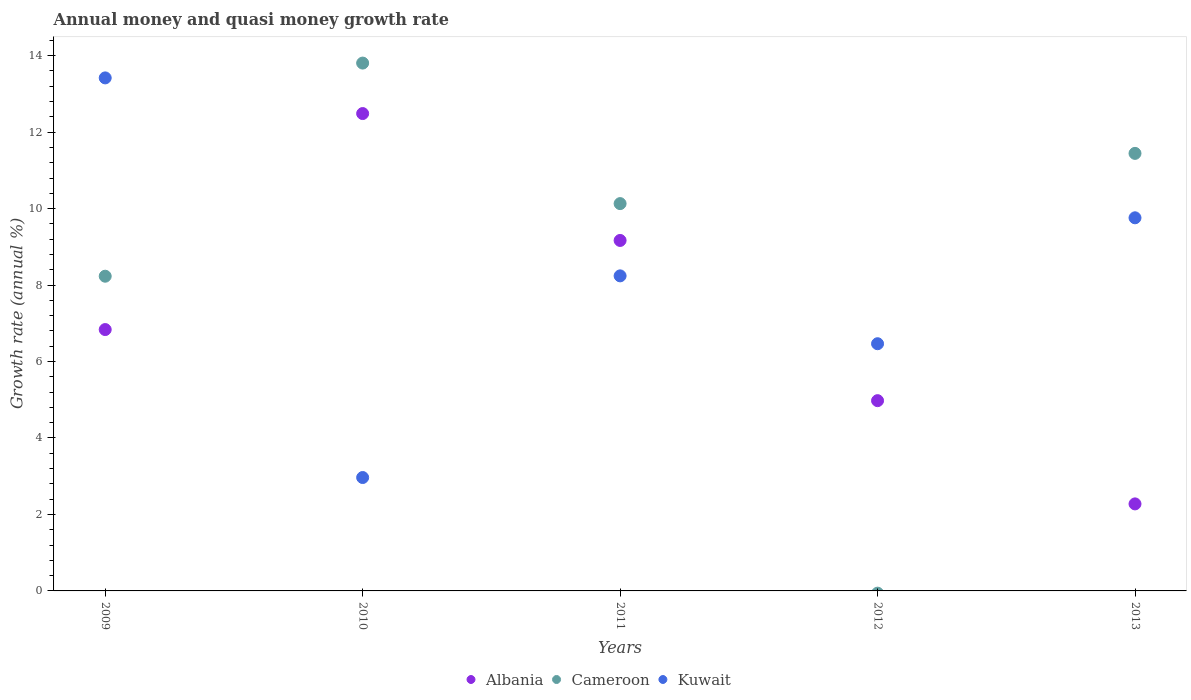Is the number of dotlines equal to the number of legend labels?
Your answer should be compact. No. What is the growth rate in Albania in 2009?
Ensure brevity in your answer.  6.84. Across all years, what is the maximum growth rate in Cameroon?
Provide a succinct answer. 13.81. Across all years, what is the minimum growth rate in Albania?
Your answer should be very brief. 2.28. What is the total growth rate in Kuwait in the graph?
Offer a very short reply. 40.85. What is the difference between the growth rate in Cameroon in 2010 and that in 2013?
Provide a succinct answer. 2.36. What is the difference between the growth rate in Kuwait in 2009 and the growth rate in Cameroon in 2010?
Provide a succinct answer. -0.39. What is the average growth rate in Albania per year?
Ensure brevity in your answer.  7.15. In the year 2010, what is the difference between the growth rate in Cameroon and growth rate in Albania?
Provide a succinct answer. 1.32. In how many years, is the growth rate in Cameroon greater than 8.4 %?
Keep it short and to the point. 3. What is the ratio of the growth rate in Cameroon in 2010 to that in 2013?
Keep it short and to the point. 1.21. Is the difference between the growth rate in Cameroon in 2011 and 2013 greater than the difference between the growth rate in Albania in 2011 and 2013?
Provide a short and direct response. No. What is the difference between the highest and the second highest growth rate in Albania?
Provide a short and direct response. 3.32. What is the difference between the highest and the lowest growth rate in Albania?
Keep it short and to the point. 10.21. In how many years, is the growth rate in Cameroon greater than the average growth rate in Cameroon taken over all years?
Your answer should be very brief. 3. Is it the case that in every year, the sum of the growth rate in Cameroon and growth rate in Albania  is greater than the growth rate in Kuwait?
Offer a terse response. No. Does the growth rate in Kuwait monotonically increase over the years?
Your response must be concise. No. How many dotlines are there?
Your response must be concise. 3. Are the values on the major ticks of Y-axis written in scientific E-notation?
Make the answer very short. No. Does the graph contain any zero values?
Ensure brevity in your answer.  Yes. Does the graph contain grids?
Offer a terse response. No. Where does the legend appear in the graph?
Offer a terse response. Bottom center. What is the title of the graph?
Your response must be concise. Annual money and quasi money growth rate. What is the label or title of the X-axis?
Give a very brief answer. Years. What is the label or title of the Y-axis?
Ensure brevity in your answer.  Growth rate (annual %). What is the Growth rate (annual %) of Albania in 2009?
Give a very brief answer. 6.84. What is the Growth rate (annual %) in Cameroon in 2009?
Ensure brevity in your answer.  8.23. What is the Growth rate (annual %) of Kuwait in 2009?
Your response must be concise. 13.42. What is the Growth rate (annual %) in Albania in 2010?
Keep it short and to the point. 12.49. What is the Growth rate (annual %) in Cameroon in 2010?
Offer a terse response. 13.81. What is the Growth rate (annual %) in Kuwait in 2010?
Your response must be concise. 2.97. What is the Growth rate (annual %) of Albania in 2011?
Your response must be concise. 9.17. What is the Growth rate (annual %) in Cameroon in 2011?
Ensure brevity in your answer.  10.13. What is the Growth rate (annual %) of Kuwait in 2011?
Offer a very short reply. 8.24. What is the Growth rate (annual %) in Albania in 2012?
Offer a very short reply. 4.98. What is the Growth rate (annual %) of Cameroon in 2012?
Your response must be concise. 0. What is the Growth rate (annual %) in Kuwait in 2012?
Your answer should be compact. 6.47. What is the Growth rate (annual %) of Albania in 2013?
Ensure brevity in your answer.  2.28. What is the Growth rate (annual %) in Cameroon in 2013?
Make the answer very short. 11.44. What is the Growth rate (annual %) of Kuwait in 2013?
Make the answer very short. 9.76. Across all years, what is the maximum Growth rate (annual %) in Albania?
Offer a very short reply. 12.49. Across all years, what is the maximum Growth rate (annual %) in Cameroon?
Provide a short and direct response. 13.81. Across all years, what is the maximum Growth rate (annual %) of Kuwait?
Offer a terse response. 13.42. Across all years, what is the minimum Growth rate (annual %) of Albania?
Keep it short and to the point. 2.28. Across all years, what is the minimum Growth rate (annual %) of Kuwait?
Your response must be concise. 2.97. What is the total Growth rate (annual %) of Albania in the graph?
Offer a terse response. 35.74. What is the total Growth rate (annual %) of Cameroon in the graph?
Your answer should be compact. 43.61. What is the total Growth rate (annual %) of Kuwait in the graph?
Make the answer very short. 40.85. What is the difference between the Growth rate (annual %) of Albania in 2009 and that in 2010?
Keep it short and to the point. -5.65. What is the difference between the Growth rate (annual %) of Cameroon in 2009 and that in 2010?
Keep it short and to the point. -5.58. What is the difference between the Growth rate (annual %) in Kuwait in 2009 and that in 2010?
Your response must be concise. 10.45. What is the difference between the Growth rate (annual %) in Albania in 2009 and that in 2011?
Your response must be concise. -2.33. What is the difference between the Growth rate (annual %) in Cameroon in 2009 and that in 2011?
Your answer should be compact. -1.9. What is the difference between the Growth rate (annual %) in Kuwait in 2009 and that in 2011?
Your response must be concise. 5.18. What is the difference between the Growth rate (annual %) of Albania in 2009 and that in 2012?
Ensure brevity in your answer.  1.86. What is the difference between the Growth rate (annual %) in Kuwait in 2009 and that in 2012?
Your response must be concise. 6.95. What is the difference between the Growth rate (annual %) in Albania in 2009 and that in 2013?
Keep it short and to the point. 4.56. What is the difference between the Growth rate (annual %) in Cameroon in 2009 and that in 2013?
Your answer should be very brief. -3.21. What is the difference between the Growth rate (annual %) in Kuwait in 2009 and that in 2013?
Offer a very short reply. 3.66. What is the difference between the Growth rate (annual %) of Albania in 2010 and that in 2011?
Give a very brief answer. 3.32. What is the difference between the Growth rate (annual %) of Cameroon in 2010 and that in 2011?
Offer a very short reply. 3.68. What is the difference between the Growth rate (annual %) in Kuwait in 2010 and that in 2011?
Your response must be concise. -5.27. What is the difference between the Growth rate (annual %) in Albania in 2010 and that in 2012?
Provide a succinct answer. 7.51. What is the difference between the Growth rate (annual %) in Kuwait in 2010 and that in 2012?
Ensure brevity in your answer.  -3.5. What is the difference between the Growth rate (annual %) of Albania in 2010 and that in 2013?
Your answer should be very brief. 10.21. What is the difference between the Growth rate (annual %) of Cameroon in 2010 and that in 2013?
Offer a very short reply. 2.36. What is the difference between the Growth rate (annual %) in Kuwait in 2010 and that in 2013?
Provide a succinct answer. -6.79. What is the difference between the Growth rate (annual %) of Albania in 2011 and that in 2012?
Give a very brief answer. 4.19. What is the difference between the Growth rate (annual %) in Kuwait in 2011 and that in 2012?
Your answer should be very brief. 1.77. What is the difference between the Growth rate (annual %) of Albania in 2011 and that in 2013?
Offer a very short reply. 6.89. What is the difference between the Growth rate (annual %) in Cameroon in 2011 and that in 2013?
Give a very brief answer. -1.31. What is the difference between the Growth rate (annual %) in Kuwait in 2011 and that in 2013?
Provide a short and direct response. -1.52. What is the difference between the Growth rate (annual %) in Albania in 2012 and that in 2013?
Offer a very short reply. 2.7. What is the difference between the Growth rate (annual %) of Kuwait in 2012 and that in 2013?
Provide a succinct answer. -3.29. What is the difference between the Growth rate (annual %) in Albania in 2009 and the Growth rate (annual %) in Cameroon in 2010?
Your response must be concise. -6.97. What is the difference between the Growth rate (annual %) of Albania in 2009 and the Growth rate (annual %) of Kuwait in 2010?
Provide a short and direct response. 3.87. What is the difference between the Growth rate (annual %) of Cameroon in 2009 and the Growth rate (annual %) of Kuwait in 2010?
Provide a short and direct response. 5.27. What is the difference between the Growth rate (annual %) in Albania in 2009 and the Growth rate (annual %) in Cameroon in 2011?
Ensure brevity in your answer.  -3.29. What is the difference between the Growth rate (annual %) in Albania in 2009 and the Growth rate (annual %) in Kuwait in 2011?
Provide a short and direct response. -1.4. What is the difference between the Growth rate (annual %) in Cameroon in 2009 and the Growth rate (annual %) in Kuwait in 2011?
Provide a succinct answer. -0.01. What is the difference between the Growth rate (annual %) in Albania in 2009 and the Growth rate (annual %) in Kuwait in 2012?
Your answer should be compact. 0.37. What is the difference between the Growth rate (annual %) in Cameroon in 2009 and the Growth rate (annual %) in Kuwait in 2012?
Offer a terse response. 1.77. What is the difference between the Growth rate (annual %) in Albania in 2009 and the Growth rate (annual %) in Cameroon in 2013?
Ensure brevity in your answer.  -4.61. What is the difference between the Growth rate (annual %) of Albania in 2009 and the Growth rate (annual %) of Kuwait in 2013?
Your response must be concise. -2.92. What is the difference between the Growth rate (annual %) in Cameroon in 2009 and the Growth rate (annual %) in Kuwait in 2013?
Your answer should be very brief. -1.53. What is the difference between the Growth rate (annual %) in Albania in 2010 and the Growth rate (annual %) in Cameroon in 2011?
Your response must be concise. 2.36. What is the difference between the Growth rate (annual %) of Albania in 2010 and the Growth rate (annual %) of Kuwait in 2011?
Offer a very short reply. 4.25. What is the difference between the Growth rate (annual %) of Cameroon in 2010 and the Growth rate (annual %) of Kuwait in 2011?
Your response must be concise. 5.57. What is the difference between the Growth rate (annual %) of Albania in 2010 and the Growth rate (annual %) of Kuwait in 2012?
Your answer should be very brief. 6.02. What is the difference between the Growth rate (annual %) of Cameroon in 2010 and the Growth rate (annual %) of Kuwait in 2012?
Ensure brevity in your answer.  7.34. What is the difference between the Growth rate (annual %) of Albania in 2010 and the Growth rate (annual %) of Cameroon in 2013?
Your answer should be compact. 1.04. What is the difference between the Growth rate (annual %) in Albania in 2010 and the Growth rate (annual %) in Kuwait in 2013?
Make the answer very short. 2.73. What is the difference between the Growth rate (annual %) of Cameroon in 2010 and the Growth rate (annual %) of Kuwait in 2013?
Provide a short and direct response. 4.05. What is the difference between the Growth rate (annual %) of Albania in 2011 and the Growth rate (annual %) of Kuwait in 2012?
Keep it short and to the point. 2.7. What is the difference between the Growth rate (annual %) in Cameroon in 2011 and the Growth rate (annual %) in Kuwait in 2012?
Offer a terse response. 3.67. What is the difference between the Growth rate (annual %) of Albania in 2011 and the Growth rate (annual %) of Cameroon in 2013?
Make the answer very short. -2.28. What is the difference between the Growth rate (annual %) of Albania in 2011 and the Growth rate (annual %) of Kuwait in 2013?
Offer a very short reply. -0.59. What is the difference between the Growth rate (annual %) in Cameroon in 2011 and the Growth rate (annual %) in Kuwait in 2013?
Make the answer very short. 0.37. What is the difference between the Growth rate (annual %) in Albania in 2012 and the Growth rate (annual %) in Cameroon in 2013?
Offer a very short reply. -6.47. What is the difference between the Growth rate (annual %) in Albania in 2012 and the Growth rate (annual %) in Kuwait in 2013?
Your answer should be compact. -4.78. What is the average Growth rate (annual %) of Albania per year?
Your answer should be very brief. 7.15. What is the average Growth rate (annual %) of Cameroon per year?
Ensure brevity in your answer.  8.72. What is the average Growth rate (annual %) of Kuwait per year?
Offer a very short reply. 8.17. In the year 2009, what is the difference between the Growth rate (annual %) in Albania and Growth rate (annual %) in Cameroon?
Provide a short and direct response. -1.4. In the year 2009, what is the difference between the Growth rate (annual %) of Albania and Growth rate (annual %) of Kuwait?
Your answer should be very brief. -6.58. In the year 2009, what is the difference between the Growth rate (annual %) in Cameroon and Growth rate (annual %) in Kuwait?
Provide a succinct answer. -5.19. In the year 2010, what is the difference between the Growth rate (annual %) in Albania and Growth rate (annual %) in Cameroon?
Offer a terse response. -1.32. In the year 2010, what is the difference between the Growth rate (annual %) in Albania and Growth rate (annual %) in Kuwait?
Your response must be concise. 9.52. In the year 2010, what is the difference between the Growth rate (annual %) in Cameroon and Growth rate (annual %) in Kuwait?
Your answer should be compact. 10.84. In the year 2011, what is the difference between the Growth rate (annual %) of Albania and Growth rate (annual %) of Cameroon?
Provide a succinct answer. -0.96. In the year 2011, what is the difference between the Growth rate (annual %) in Albania and Growth rate (annual %) in Kuwait?
Provide a succinct answer. 0.93. In the year 2011, what is the difference between the Growth rate (annual %) in Cameroon and Growth rate (annual %) in Kuwait?
Make the answer very short. 1.89. In the year 2012, what is the difference between the Growth rate (annual %) of Albania and Growth rate (annual %) of Kuwait?
Your response must be concise. -1.49. In the year 2013, what is the difference between the Growth rate (annual %) of Albania and Growth rate (annual %) of Cameroon?
Offer a terse response. -9.17. In the year 2013, what is the difference between the Growth rate (annual %) of Albania and Growth rate (annual %) of Kuwait?
Offer a terse response. -7.48. In the year 2013, what is the difference between the Growth rate (annual %) of Cameroon and Growth rate (annual %) of Kuwait?
Provide a short and direct response. 1.69. What is the ratio of the Growth rate (annual %) of Albania in 2009 to that in 2010?
Make the answer very short. 0.55. What is the ratio of the Growth rate (annual %) in Cameroon in 2009 to that in 2010?
Keep it short and to the point. 0.6. What is the ratio of the Growth rate (annual %) of Kuwait in 2009 to that in 2010?
Ensure brevity in your answer.  4.52. What is the ratio of the Growth rate (annual %) of Albania in 2009 to that in 2011?
Provide a succinct answer. 0.75. What is the ratio of the Growth rate (annual %) in Cameroon in 2009 to that in 2011?
Offer a terse response. 0.81. What is the ratio of the Growth rate (annual %) of Kuwait in 2009 to that in 2011?
Provide a short and direct response. 1.63. What is the ratio of the Growth rate (annual %) of Albania in 2009 to that in 2012?
Keep it short and to the point. 1.37. What is the ratio of the Growth rate (annual %) in Kuwait in 2009 to that in 2012?
Provide a short and direct response. 2.08. What is the ratio of the Growth rate (annual %) of Albania in 2009 to that in 2013?
Keep it short and to the point. 3. What is the ratio of the Growth rate (annual %) of Cameroon in 2009 to that in 2013?
Offer a very short reply. 0.72. What is the ratio of the Growth rate (annual %) in Kuwait in 2009 to that in 2013?
Offer a terse response. 1.38. What is the ratio of the Growth rate (annual %) in Albania in 2010 to that in 2011?
Provide a short and direct response. 1.36. What is the ratio of the Growth rate (annual %) of Cameroon in 2010 to that in 2011?
Offer a very short reply. 1.36. What is the ratio of the Growth rate (annual %) in Kuwait in 2010 to that in 2011?
Give a very brief answer. 0.36. What is the ratio of the Growth rate (annual %) in Albania in 2010 to that in 2012?
Provide a short and direct response. 2.51. What is the ratio of the Growth rate (annual %) in Kuwait in 2010 to that in 2012?
Ensure brevity in your answer.  0.46. What is the ratio of the Growth rate (annual %) of Albania in 2010 to that in 2013?
Provide a short and direct response. 5.49. What is the ratio of the Growth rate (annual %) in Cameroon in 2010 to that in 2013?
Offer a terse response. 1.21. What is the ratio of the Growth rate (annual %) of Kuwait in 2010 to that in 2013?
Offer a very short reply. 0.3. What is the ratio of the Growth rate (annual %) of Albania in 2011 to that in 2012?
Give a very brief answer. 1.84. What is the ratio of the Growth rate (annual %) in Kuwait in 2011 to that in 2012?
Make the answer very short. 1.27. What is the ratio of the Growth rate (annual %) of Albania in 2011 to that in 2013?
Offer a terse response. 4.03. What is the ratio of the Growth rate (annual %) of Cameroon in 2011 to that in 2013?
Make the answer very short. 0.89. What is the ratio of the Growth rate (annual %) of Kuwait in 2011 to that in 2013?
Your response must be concise. 0.84. What is the ratio of the Growth rate (annual %) in Albania in 2012 to that in 2013?
Your answer should be very brief. 2.19. What is the ratio of the Growth rate (annual %) of Kuwait in 2012 to that in 2013?
Your answer should be very brief. 0.66. What is the difference between the highest and the second highest Growth rate (annual %) of Albania?
Provide a short and direct response. 3.32. What is the difference between the highest and the second highest Growth rate (annual %) in Cameroon?
Provide a short and direct response. 2.36. What is the difference between the highest and the second highest Growth rate (annual %) in Kuwait?
Offer a terse response. 3.66. What is the difference between the highest and the lowest Growth rate (annual %) in Albania?
Keep it short and to the point. 10.21. What is the difference between the highest and the lowest Growth rate (annual %) in Cameroon?
Keep it short and to the point. 13.81. What is the difference between the highest and the lowest Growth rate (annual %) of Kuwait?
Provide a short and direct response. 10.45. 